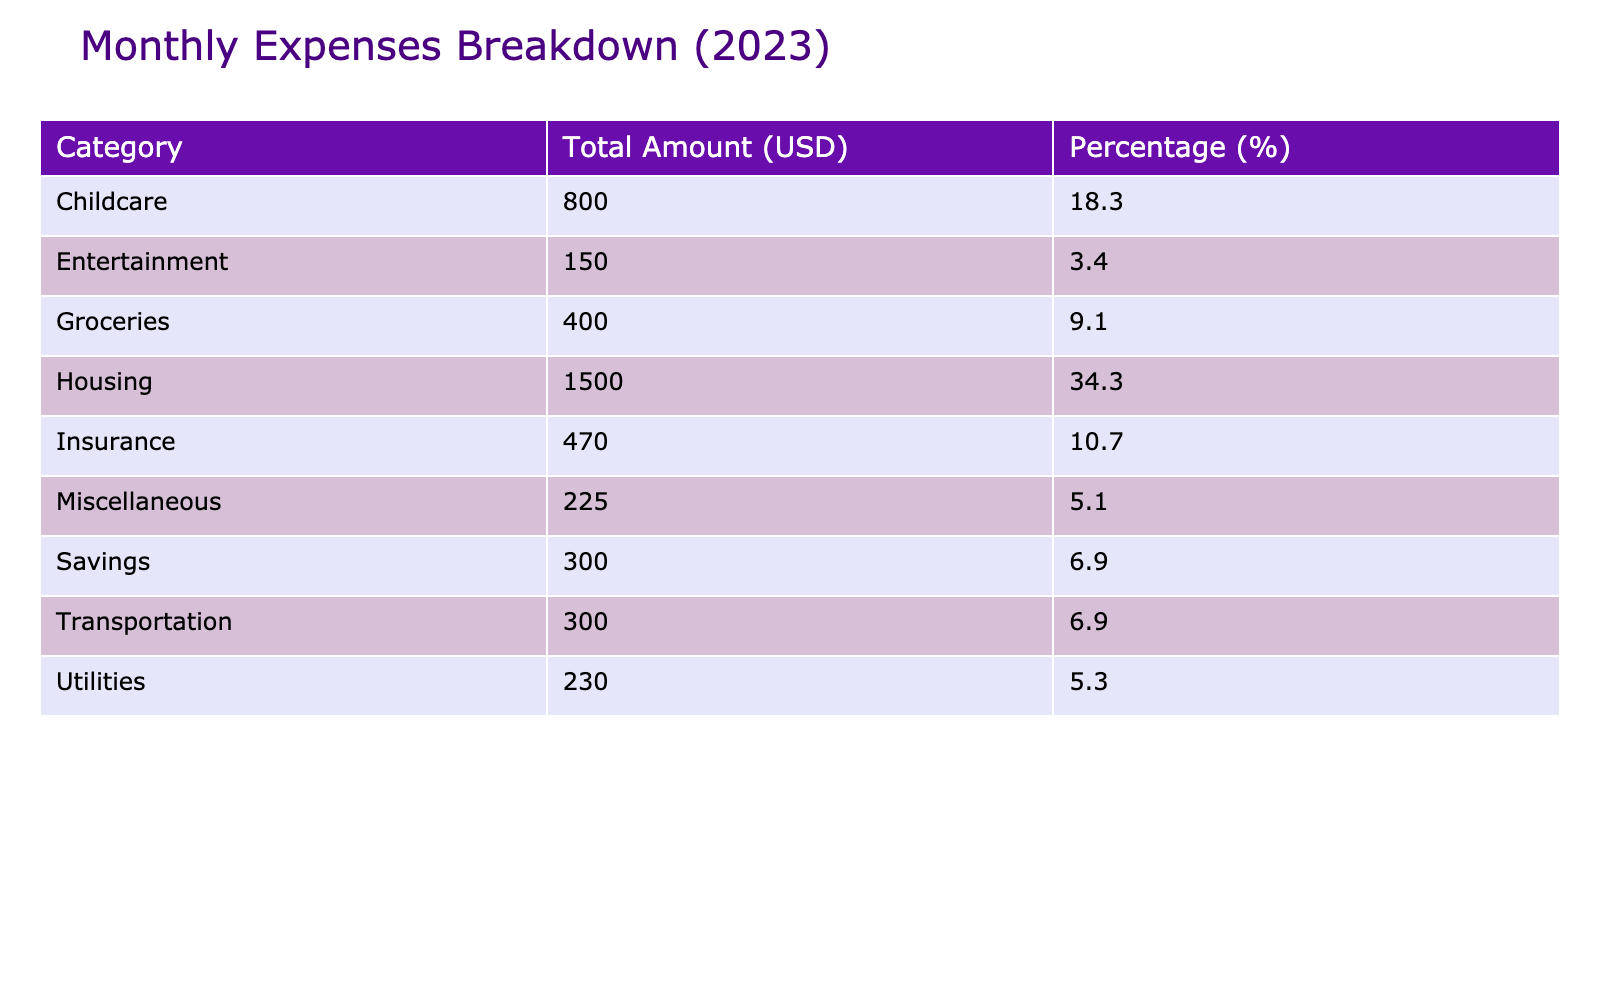What is the total amount spent on housing? The total amount spent on housing can be found specifically in the "Housing" category, which lists Rent/Mortgage as 1500. Therefore, the total amount for housing is simply 1500.
Answer: 1500 How much does the family spend on utilities in total? The utilities category includes Electricity (120), Water (50), and Internet (60). Adding these amounts together (120 + 50 + 60) gives a total of 230.
Answer: 230 What percentage of the total monthly expenses is dedicated to childcare? To find the percentage for childcare, first look at the Childcare category which shows 800. Next, we need the grand total of all expenses which is calculated as ($1500 + $230 + $400 + $300 + $200 + $100 + $350 + $120 + $800 + $150 + $300 + $150 + $75 = $4325). Now calculate the percentage as (800 / 4325) * 100, which is approximately 18.5%.
Answer: 18.5 Is the total amount spent on groceries more than that spent on entertainment? The grocery total is 400, while entertainment shows 150. Since 400 is greater than 150, the statement is true.
Answer: Yes What is the combined total of the family's transportation and entertainment expenses? Transportation includes Gas (200) and Public Transit (100), adding up to 300. Entertainment is 150. Therefore, the total combined is (300 + 150 = 450).
Answer: 450 What is the total amount spent on insurance? The insurance category lists two expenses: Health Insurance (350) and Car Insurance (120). Adding these together (350 + 120) equals 470.
Answer: 470 What is the average amount spent across all categories? There are 13 total entries across various categories in the table. The grand total of all expenses is 4325, and to find the average, we divide by 13. Thus, the average is 4325 / 13, which is roughly 333.85.
Answer: 333.85 If the family wants to cut down expenses by 10%, how much will they save? The total monthly expenses amount to 4325. To calculate a 10% reduction, multiply by 0.10 (4325 * 0.10), which equals 432.5. Thus, they'd save approximately 432.5 if they reduce expenses by 10%.
Answer: 432.5 How much does the family spend on miscellaneous expenses? The miscellaneous category consists of Clothing (150) and Medical Expenses (75). Adding these amounts together (150 + 75) gives a total of 225.
Answer: 225 